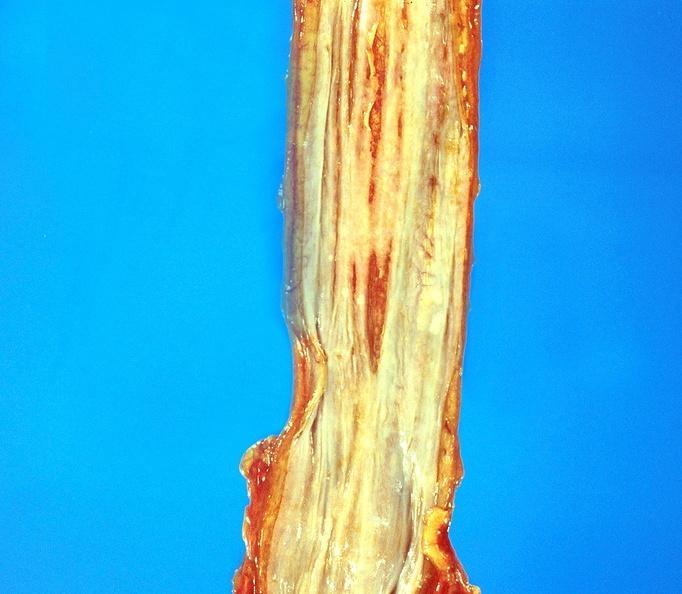does this image show esophageal varices?
Answer the question using a single word or phrase. Yes 